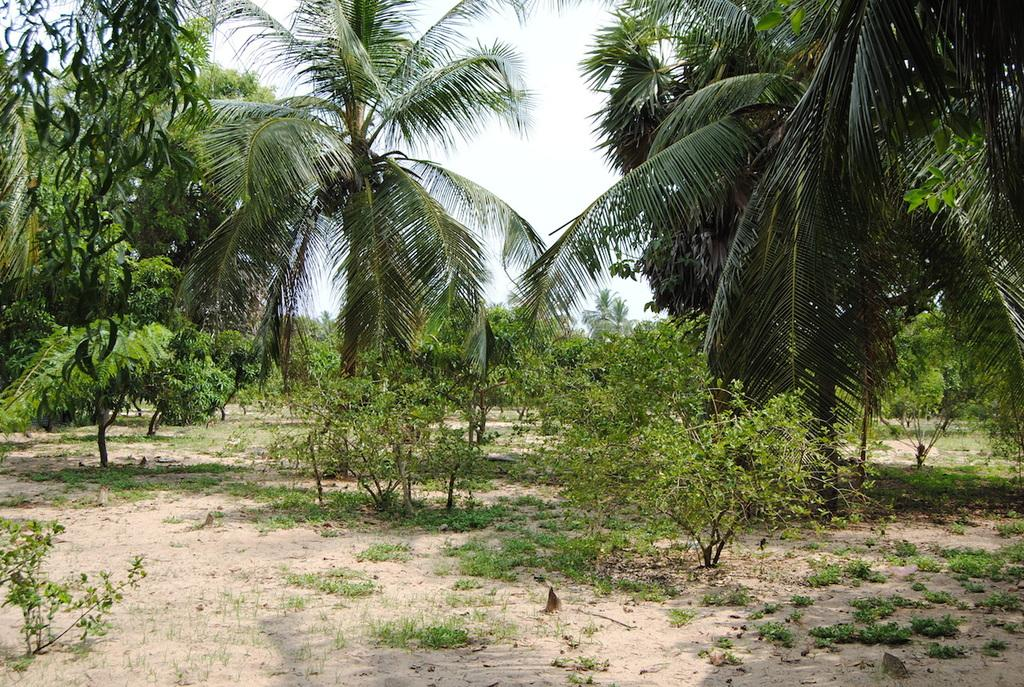What type of vegetation can be seen in the background of the image? There are trees in the background of the image. What other types of vegetation are visible in the image? There are plants visible in the image. What is at the bottom of the image? There is grass at the bottom of the image. What is visible at the top of the image? The sky is visible at the top of the image. How many tickets are visible in the image? There are no tickets present in the image. What is the relation between the plants and the grass in the image? There is no direct relation between the plants and the grass in the image; they are simply different types of vegetation. 